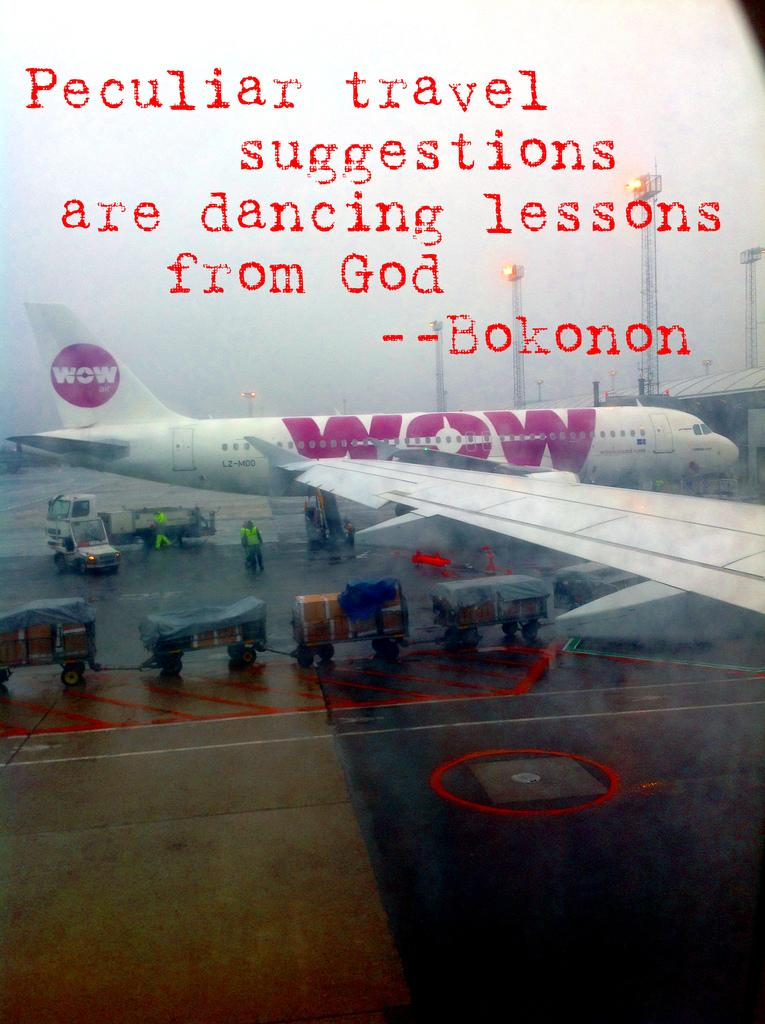What is the main subject of the image? The main subject of the image is an airplane. What other vehicles are present in the image? There are trucks around the airplane. What type of vehicles are used for transporting goods in the image? There are goods carriers in the image. Can you tell if the image has been altered or edited? Yes, the image appears to be edited. What additional text or message is present in the image? There is a quotation written above the airplane. Can you see any waves or harbor in the image? No, there are no waves or harbor present in the image. Are there any worms visible in the image? No, there are no worms visible in the image. 